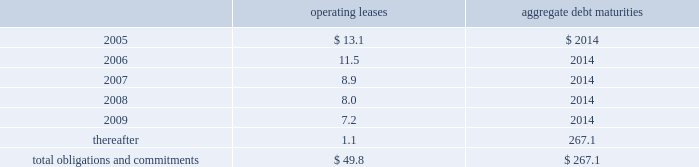Edwards lifesciences corporation notes to consolidated financial statements 2014 ( continued ) future minimum lease payments ( including interest ) under noncancelable operating leases and aggregate debt maturities at december 31 , 2004 were as follows ( in millions ) : aggregate operating debt leases maturities 2005*************************************************************** $ 13.1 $ 2014 2006*************************************************************** 11.5 2014 2007*************************************************************** 8.9 2014 2008*************************************************************** 8.0 2014 2009*************************************************************** 7.2 2014 thereafter ********************************************************** 1.1 267.1 total obligations and commitments************************************** $ 49.8 $ 267.1 included in debt at december 31 , 2004 and 2003 were unsecured notes denominated in japanese yen of a57.0 billion ( us$ 67.1 million ) and a56.0 billion ( us$ 55.8 million ) , respectively .
Certain facilities and equipment are leased under operating leases expiring at various dates .
Most of the operating leases contain renewal options .
Total expense for all operating leases was $ 14.0 million , $ 12.3 million , and $ 6.8 million for the years 2004 , 2003 and 2002 , respectively .
11 .
Financial instruments and risk management fair values of financial instruments the consolidated financial statements include financial instruments whereby the fair market value of such instruments may differ from amounts reflected on a historical basis .
Financial instruments of the company consist of cash deposits , accounts and other receivables , investments in unconsolidated affiliates , accounts payable , certain accrued liabilities and debt .
The fair values of certain investments in unconsolidated affiliates are estimated based on quoted market prices .
For other investments , various methods are used to estimate fair value , including external valuations and discounted cash flows .
The carrying amount of the company 2019s long-term debt approximates fair market value based on prevailing market rates .
The company 2019s other financial instruments generally approximate their fair values based on the short-term nature of these instruments. .
Edwards lifesciences corporation notes to consolidated financial statements 2014 ( continued ) future minimum lease payments ( including interest ) under noncancelable operating leases and aggregate debt maturities at december 31 , 2004 were as follows ( in millions ) : aggregate operating debt leases maturities 2005*************************************************************** $ 13.1 $ 2014 2006*************************************************************** 11.5 2014 2007*************************************************************** 8.9 2014 2008*************************************************************** 8.0 2014 2009*************************************************************** 7.2 2014 thereafter ********************************************************** 1.1 267.1 total obligations and commitments************************************** $ 49.8 $ 267.1 included in debt at december 31 , 2004 and 2003 were unsecured notes denominated in japanese yen of a57.0 billion ( us$ 67.1 million ) and a56.0 billion ( us$ 55.8 million ) , respectively .
Certain facilities and equipment are leased under operating leases expiring at various dates .
Most of the operating leases contain renewal options .
Total expense for all operating leases was $ 14.0 million , $ 12.3 million , and $ 6.8 million for the years 2004 , 2003 and 2002 , respectively .
11 .
Financial instruments and risk management fair values of financial instruments the consolidated financial statements include financial instruments whereby the fair market value of such instruments may differ from amounts reflected on a historical basis .
Financial instruments of the company consist of cash deposits , accounts and other receivables , investments in unconsolidated affiliates , accounts payable , certain accrued liabilities and debt .
The fair values of certain investments in unconsolidated affiliates are estimated based on quoted market prices .
For other investments , various methods are used to estimate fair value , including external valuations and discounted cash flows .
The carrying amount of the company 2019s long-term debt approximates fair market value based on prevailing market rates .
The company 2019s other financial instruments generally approximate their fair values based on the short-term nature of these instruments. .
What was the percentage change in total expense for all operating leases between 2003 and 2004? 
Computations: ((14.0 - 12.3) / 12.3)
Answer: 0.13821. 